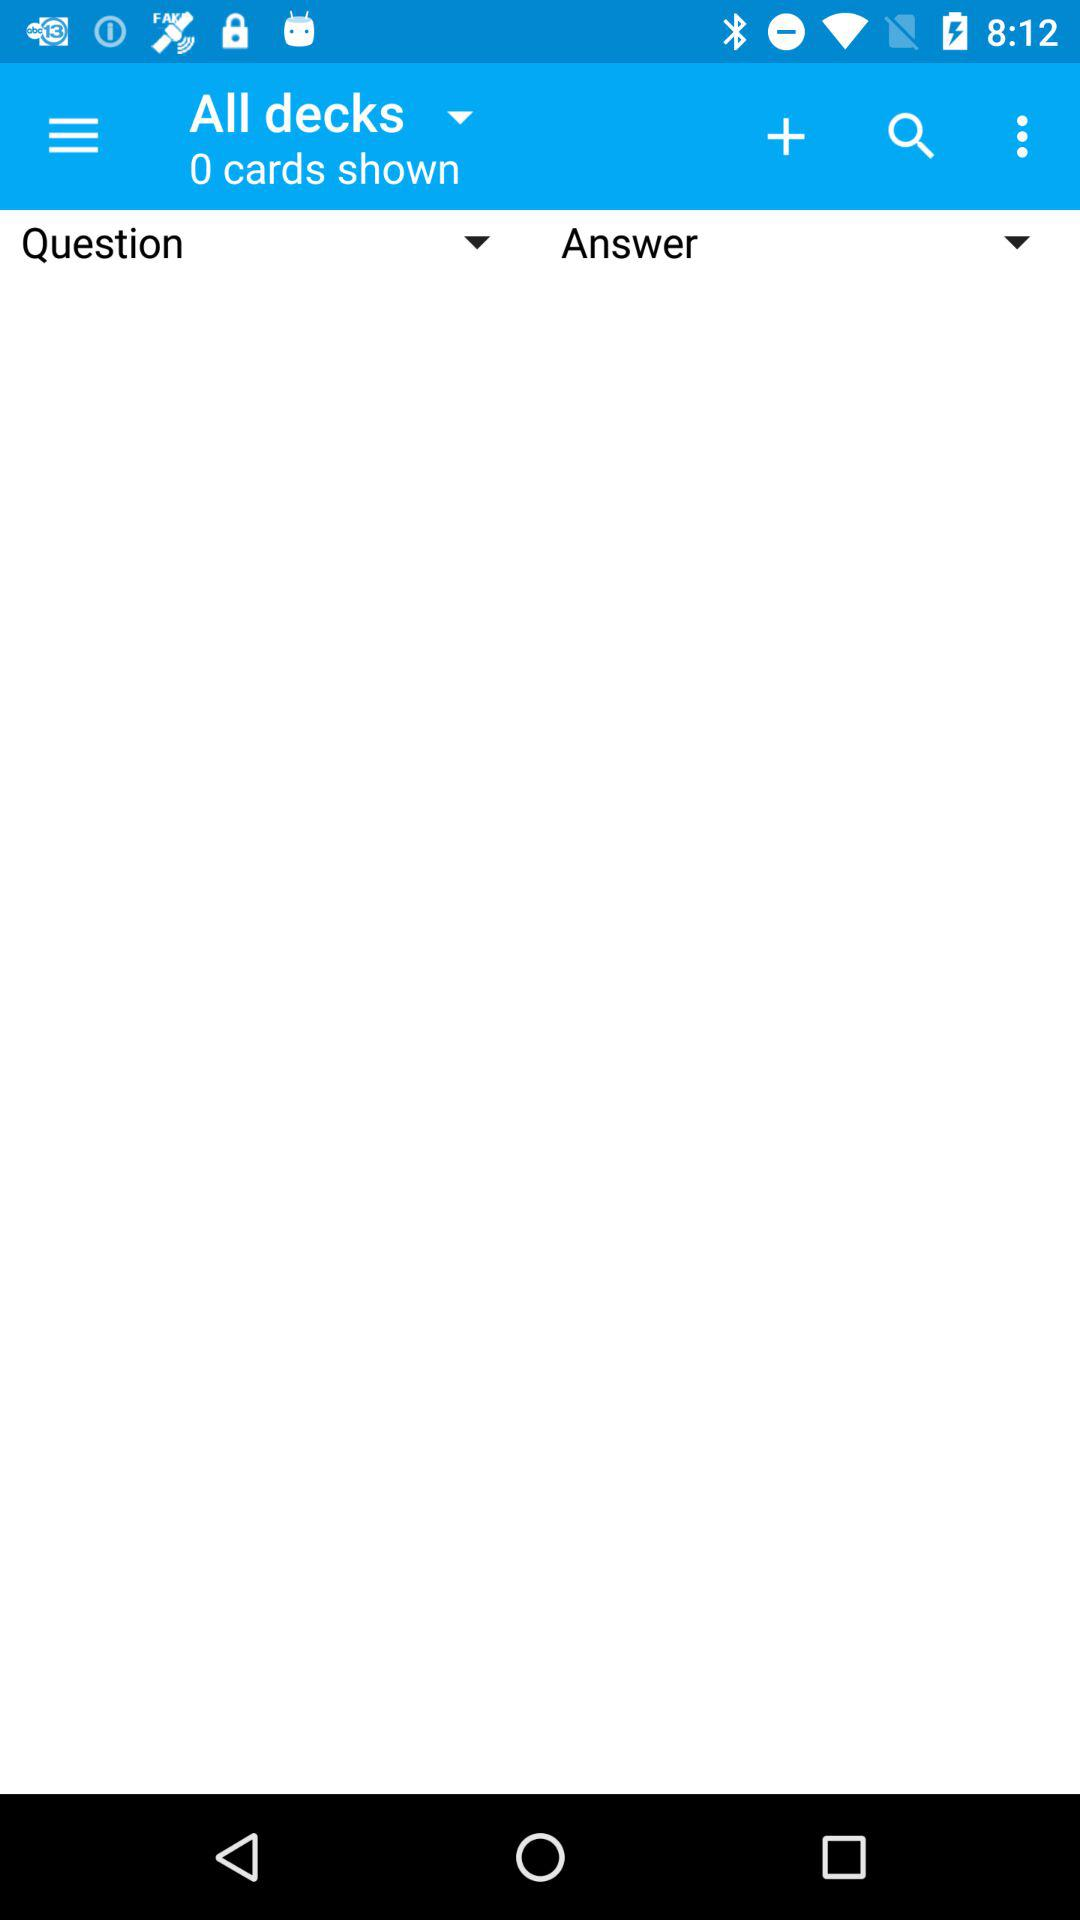How many cards are shown in the deck?
Answer the question using a single word or phrase. 0 